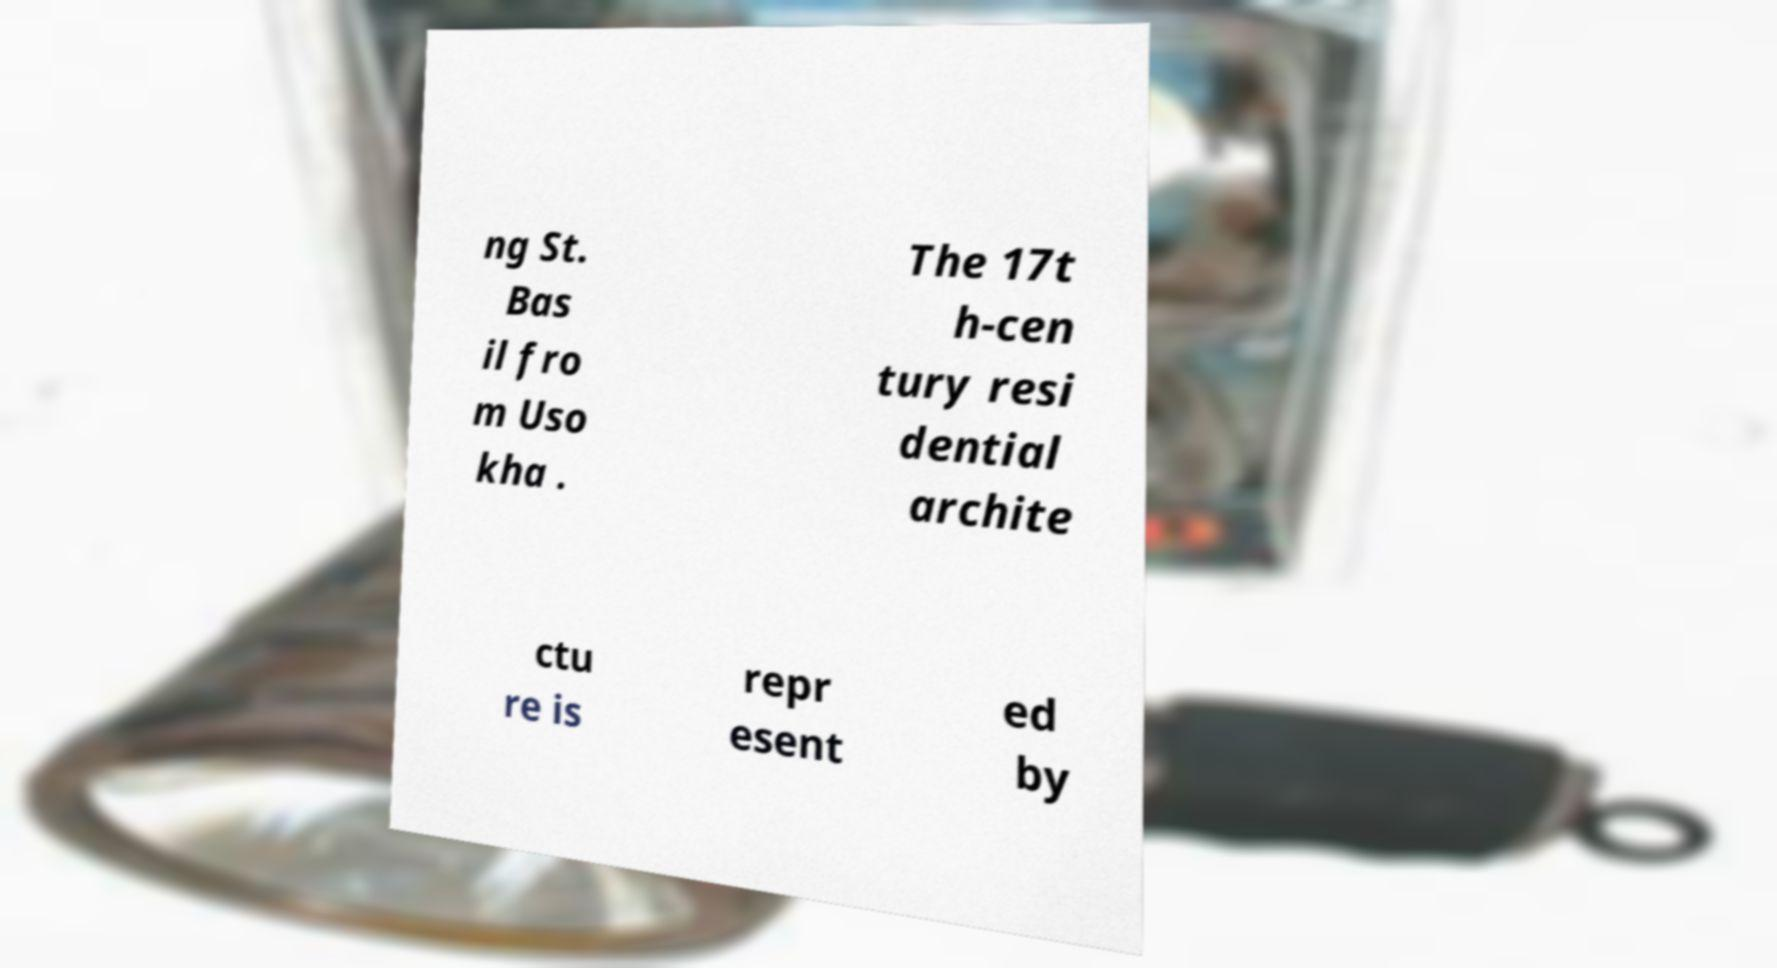I need the written content from this picture converted into text. Can you do that? ng St. Bas il fro m Uso kha . The 17t h-cen tury resi dential archite ctu re is repr esent ed by 